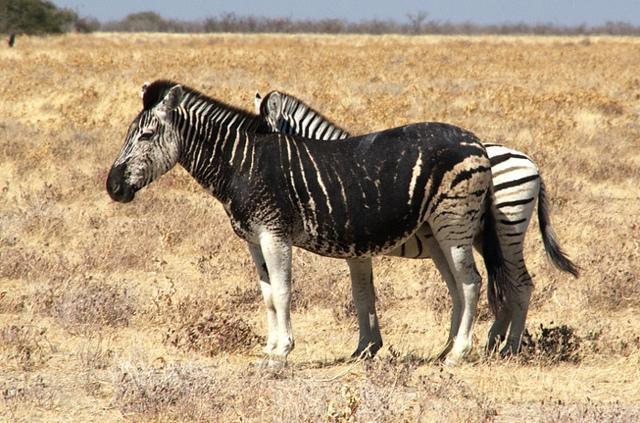How many zebras are there?
Give a very brief answer. 2. 